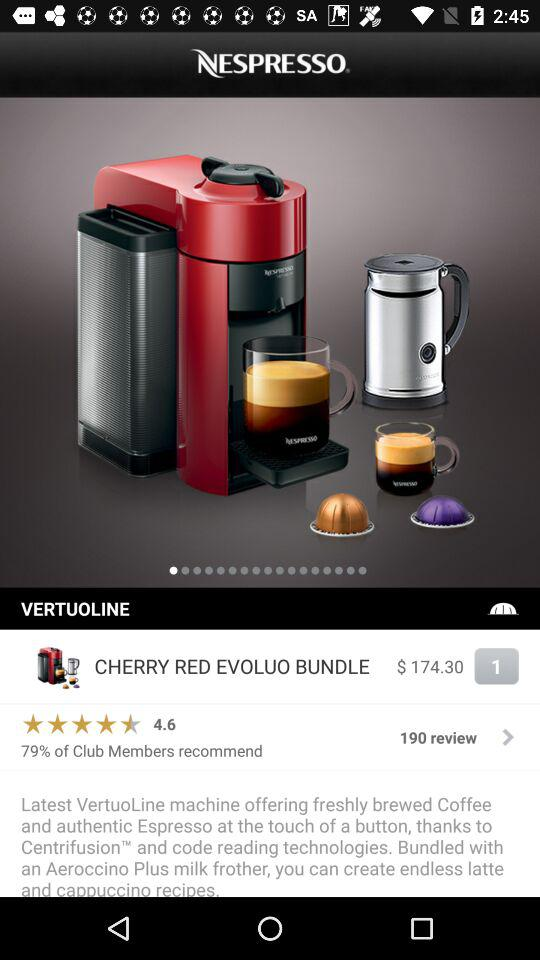How many members have joined club?
When the provided information is insufficient, respond with <no answer>. <no answer> 